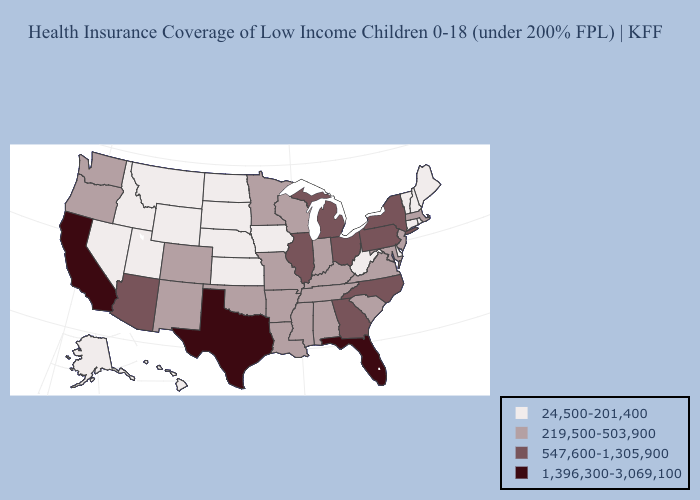What is the value of Wyoming?
Keep it brief. 24,500-201,400. Name the states that have a value in the range 24,500-201,400?
Keep it brief. Alaska, Connecticut, Delaware, Hawaii, Idaho, Iowa, Kansas, Maine, Montana, Nebraska, Nevada, New Hampshire, North Dakota, Rhode Island, South Dakota, Utah, Vermont, West Virginia, Wyoming. Does Alabama have the lowest value in the USA?
Concise answer only. No. Does Tennessee have the same value as Ohio?
Short answer required. No. Among the states that border Colorado , does Oklahoma have the highest value?
Concise answer only. No. Name the states that have a value in the range 24,500-201,400?
Keep it brief. Alaska, Connecticut, Delaware, Hawaii, Idaho, Iowa, Kansas, Maine, Montana, Nebraska, Nevada, New Hampshire, North Dakota, Rhode Island, South Dakota, Utah, Vermont, West Virginia, Wyoming. Does Michigan have the same value as Mississippi?
Write a very short answer. No. Among the states that border Alabama , does Florida have the highest value?
Give a very brief answer. Yes. What is the value of Kansas?
Answer briefly. 24,500-201,400. Name the states that have a value in the range 24,500-201,400?
Be succinct. Alaska, Connecticut, Delaware, Hawaii, Idaho, Iowa, Kansas, Maine, Montana, Nebraska, Nevada, New Hampshire, North Dakota, Rhode Island, South Dakota, Utah, Vermont, West Virginia, Wyoming. Which states have the highest value in the USA?
Give a very brief answer. California, Florida, Texas. Which states have the lowest value in the USA?
Answer briefly. Alaska, Connecticut, Delaware, Hawaii, Idaho, Iowa, Kansas, Maine, Montana, Nebraska, Nevada, New Hampshire, North Dakota, Rhode Island, South Dakota, Utah, Vermont, West Virginia, Wyoming. What is the highest value in states that border Oklahoma?
Concise answer only. 1,396,300-3,069,100. Does Illinois have the highest value in the USA?
Short answer required. No. What is the value of Wyoming?
Quick response, please. 24,500-201,400. 